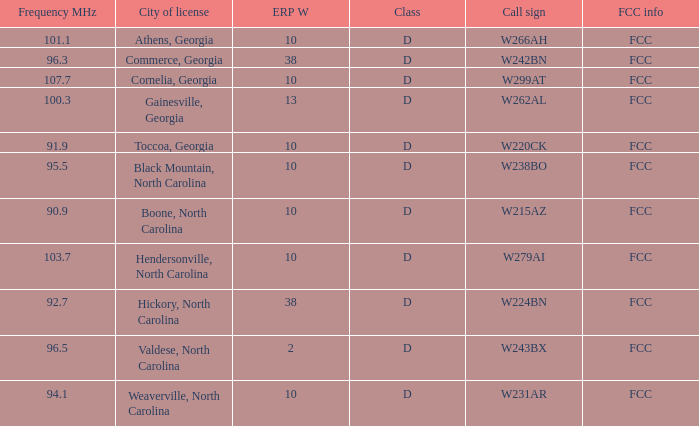What city has larger than 94.1 as a frequency? Athens, Georgia, Commerce, Georgia, Cornelia, Georgia, Gainesville, Georgia, Black Mountain, North Carolina, Hendersonville, North Carolina, Valdese, North Carolina. 